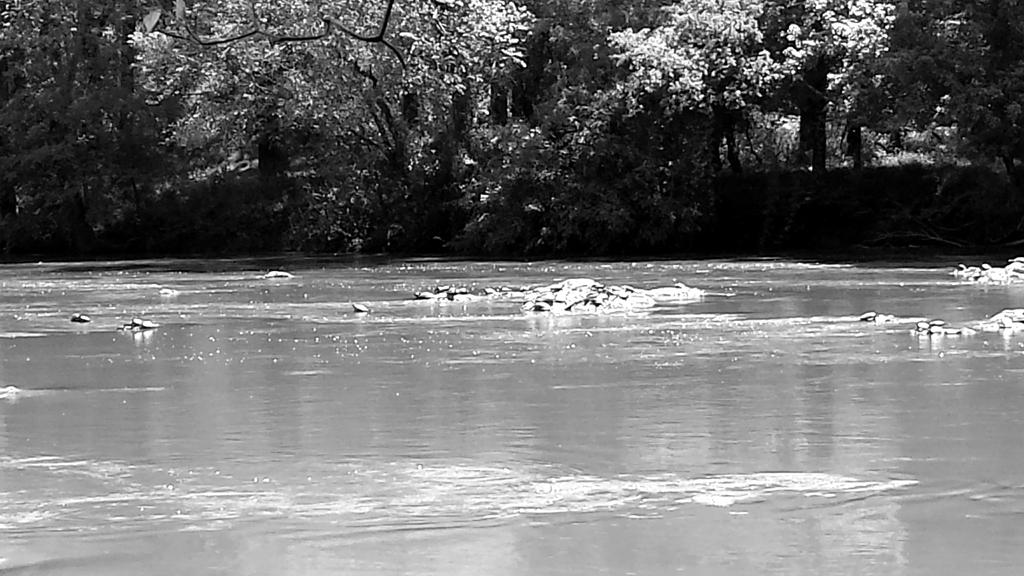What is the color scheme of the image? The picture is black and white. What natural element can be seen in the image? There is water visible in the image. What type of vegetation is present in the image? There are trees in the image. What type of garden can be seen in the image? There is no garden present in the image; it features water and trees in a black and white color scheme. What type of protest is taking place in the image? There is no protest present in the image; it features water and trees in a black and white color scheme. 